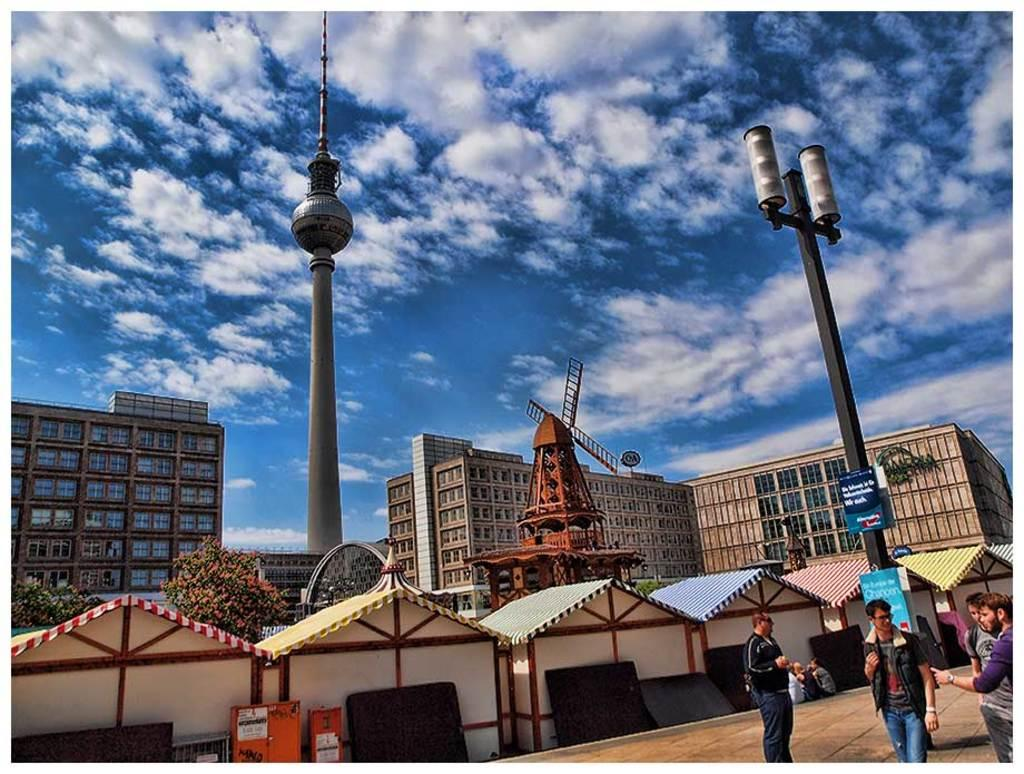What can be seen on the right side of the image? There are people on the right side of the image. What is located in the middle of the image? There are buildings in the middle of the image, including a windmill house. What is visible at the top of the image? The sky is visible at the top of the image. How many balloons are tied to the windmill house in the image? There are no balloons present in the image; the focus is on the windmill house and the people nearby. Can you describe the friction between the ducks and the windmill house in the image? There are no ducks present in the image, so it is not possible to describe any friction between them and the windmill house. 